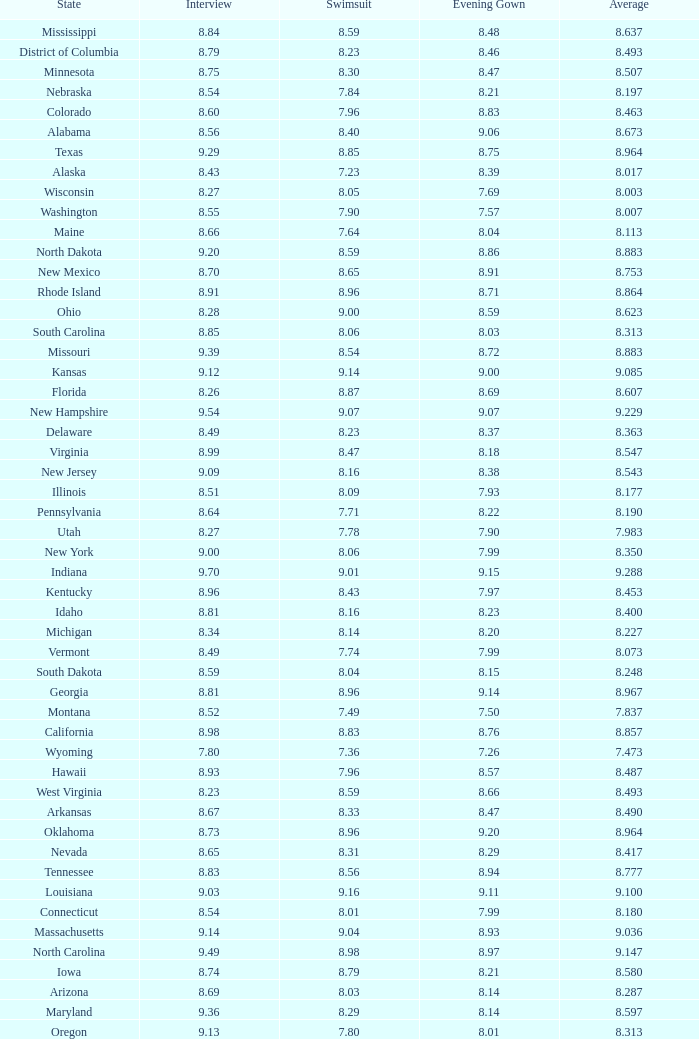Name the total number of swimsuits for evening gowns less than 8.21 and average of 8.453 with interview less than 9.09 1.0. 